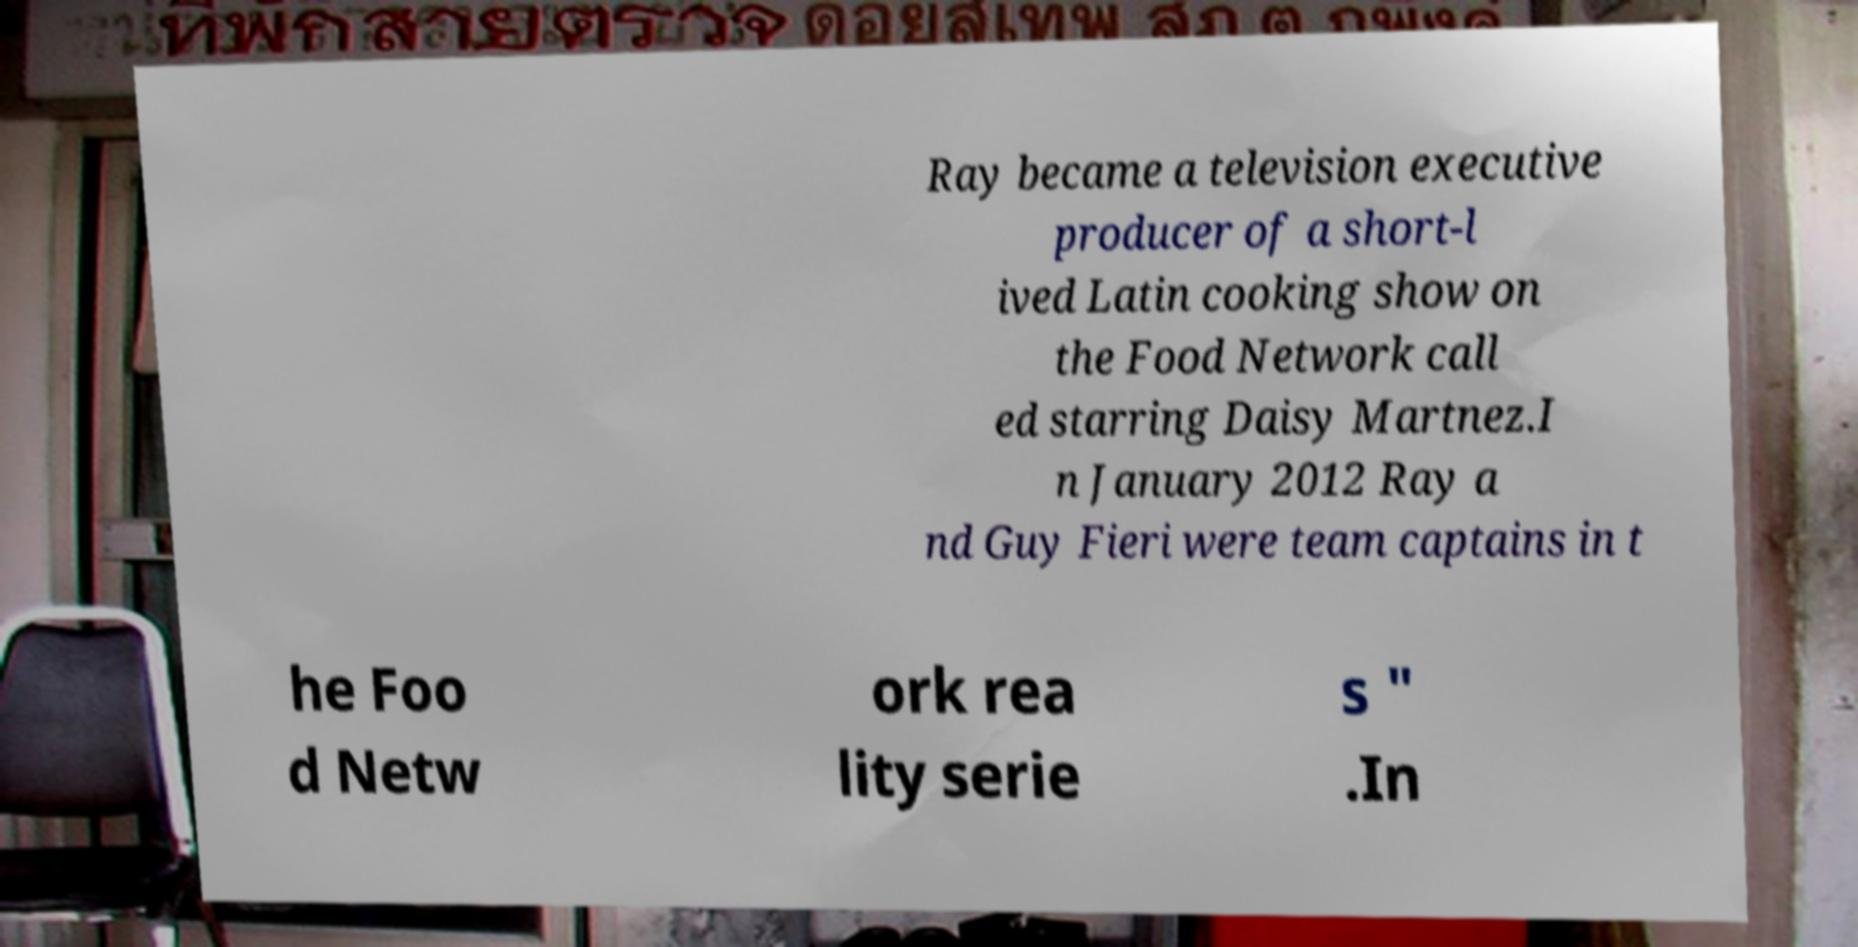What messages or text are displayed in this image? I need them in a readable, typed format. Ray became a television executive producer of a short-l ived Latin cooking show on the Food Network call ed starring Daisy Martnez.I n January 2012 Ray a nd Guy Fieri were team captains in t he Foo d Netw ork rea lity serie s " .In 